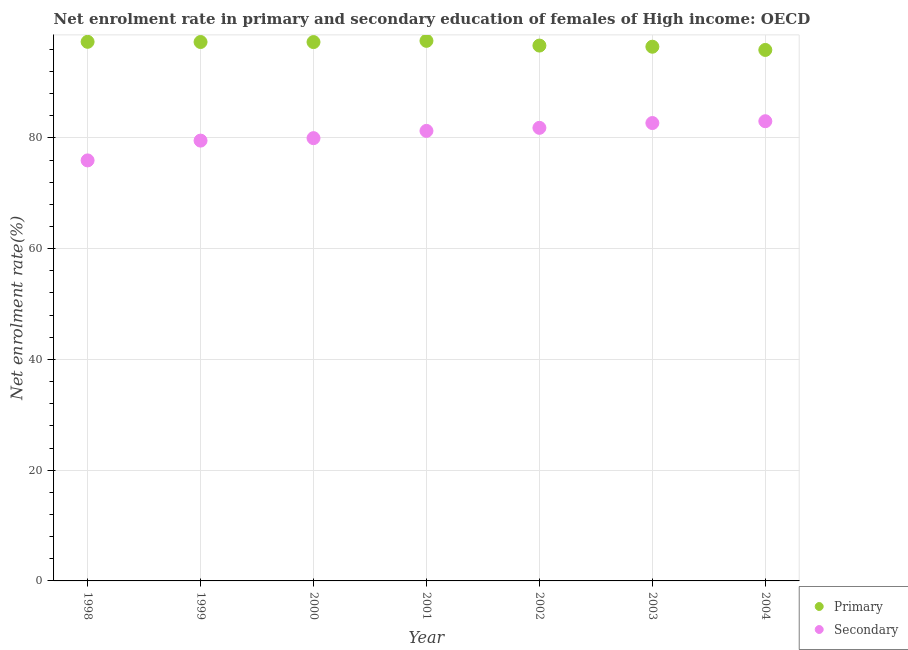How many different coloured dotlines are there?
Give a very brief answer. 2. Is the number of dotlines equal to the number of legend labels?
Your response must be concise. Yes. What is the enrollment rate in secondary education in 1998?
Offer a terse response. 75.95. Across all years, what is the maximum enrollment rate in primary education?
Make the answer very short. 97.54. Across all years, what is the minimum enrollment rate in secondary education?
Offer a very short reply. 75.95. In which year was the enrollment rate in primary education maximum?
Your response must be concise. 2001. What is the total enrollment rate in primary education in the graph?
Keep it short and to the point. 678.61. What is the difference between the enrollment rate in primary education in 2000 and that in 2002?
Make the answer very short. 0.63. What is the difference between the enrollment rate in secondary education in 2000 and the enrollment rate in primary education in 2004?
Keep it short and to the point. -15.93. What is the average enrollment rate in secondary education per year?
Provide a short and direct response. 80.61. In the year 2002, what is the difference between the enrollment rate in secondary education and enrollment rate in primary education?
Make the answer very short. -14.86. In how many years, is the enrollment rate in secondary education greater than 92 %?
Give a very brief answer. 0. What is the ratio of the enrollment rate in secondary education in 1998 to that in 2001?
Provide a succinct answer. 0.93. Is the enrollment rate in secondary education in 1999 less than that in 2001?
Give a very brief answer. Yes. Is the difference between the enrollment rate in secondary education in 2001 and 2002 greater than the difference between the enrollment rate in primary education in 2001 and 2002?
Offer a terse response. No. What is the difference between the highest and the second highest enrollment rate in primary education?
Give a very brief answer. 0.17. What is the difference between the highest and the lowest enrollment rate in secondary education?
Your answer should be very brief. 7.08. Is the sum of the enrollment rate in primary education in 1998 and 2004 greater than the maximum enrollment rate in secondary education across all years?
Your answer should be compact. Yes. Is the enrollment rate in secondary education strictly less than the enrollment rate in primary education over the years?
Your answer should be compact. Yes. How many dotlines are there?
Offer a very short reply. 2. How many years are there in the graph?
Offer a terse response. 7. Does the graph contain any zero values?
Ensure brevity in your answer.  No. Where does the legend appear in the graph?
Offer a terse response. Bottom right. How are the legend labels stacked?
Keep it short and to the point. Vertical. What is the title of the graph?
Keep it short and to the point. Net enrolment rate in primary and secondary education of females of High income: OECD. Does "Boys" appear as one of the legend labels in the graph?
Your answer should be compact. No. What is the label or title of the X-axis?
Provide a succinct answer. Year. What is the label or title of the Y-axis?
Your response must be concise. Net enrolment rate(%). What is the Net enrolment rate(%) in Primary in 1998?
Your answer should be very brief. 97.36. What is the Net enrolment rate(%) in Secondary in 1998?
Make the answer very short. 75.95. What is the Net enrolment rate(%) in Primary in 1999?
Your answer should be compact. 97.33. What is the Net enrolment rate(%) of Secondary in 1999?
Give a very brief answer. 79.52. What is the Net enrolment rate(%) in Primary in 2000?
Your response must be concise. 97.32. What is the Net enrolment rate(%) in Secondary in 2000?
Give a very brief answer. 79.97. What is the Net enrolment rate(%) in Primary in 2001?
Make the answer very short. 97.54. What is the Net enrolment rate(%) in Secondary in 2001?
Offer a terse response. 81.28. What is the Net enrolment rate(%) of Primary in 2002?
Provide a short and direct response. 96.69. What is the Net enrolment rate(%) of Secondary in 2002?
Your answer should be compact. 81.83. What is the Net enrolment rate(%) in Primary in 2003?
Your answer should be compact. 96.48. What is the Net enrolment rate(%) in Secondary in 2003?
Provide a succinct answer. 82.69. What is the Net enrolment rate(%) of Primary in 2004?
Your answer should be compact. 95.9. What is the Net enrolment rate(%) of Secondary in 2004?
Offer a terse response. 83.02. Across all years, what is the maximum Net enrolment rate(%) in Primary?
Make the answer very short. 97.54. Across all years, what is the maximum Net enrolment rate(%) in Secondary?
Offer a very short reply. 83.02. Across all years, what is the minimum Net enrolment rate(%) in Primary?
Your answer should be compact. 95.9. Across all years, what is the minimum Net enrolment rate(%) of Secondary?
Keep it short and to the point. 75.95. What is the total Net enrolment rate(%) in Primary in the graph?
Ensure brevity in your answer.  678.61. What is the total Net enrolment rate(%) in Secondary in the graph?
Offer a terse response. 564.26. What is the difference between the Net enrolment rate(%) in Primary in 1998 and that in 1999?
Your response must be concise. 0.04. What is the difference between the Net enrolment rate(%) in Secondary in 1998 and that in 1999?
Provide a succinct answer. -3.58. What is the difference between the Net enrolment rate(%) in Primary in 1998 and that in 2000?
Offer a terse response. 0.05. What is the difference between the Net enrolment rate(%) in Secondary in 1998 and that in 2000?
Offer a terse response. -4.02. What is the difference between the Net enrolment rate(%) in Primary in 1998 and that in 2001?
Your response must be concise. -0.17. What is the difference between the Net enrolment rate(%) of Secondary in 1998 and that in 2001?
Give a very brief answer. -5.33. What is the difference between the Net enrolment rate(%) in Primary in 1998 and that in 2002?
Provide a short and direct response. 0.68. What is the difference between the Net enrolment rate(%) in Secondary in 1998 and that in 2002?
Offer a terse response. -5.88. What is the difference between the Net enrolment rate(%) of Primary in 1998 and that in 2003?
Make the answer very short. 0.89. What is the difference between the Net enrolment rate(%) of Secondary in 1998 and that in 2003?
Provide a succinct answer. -6.75. What is the difference between the Net enrolment rate(%) of Primary in 1998 and that in 2004?
Provide a short and direct response. 1.47. What is the difference between the Net enrolment rate(%) in Secondary in 1998 and that in 2004?
Make the answer very short. -7.08. What is the difference between the Net enrolment rate(%) in Primary in 1999 and that in 2000?
Provide a succinct answer. 0.01. What is the difference between the Net enrolment rate(%) of Secondary in 1999 and that in 2000?
Your response must be concise. -0.45. What is the difference between the Net enrolment rate(%) of Primary in 1999 and that in 2001?
Keep it short and to the point. -0.21. What is the difference between the Net enrolment rate(%) of Secondary in 1999 and that in 2001?
Make the answer very short. -1.75. What is the difference between the Net enrolment rate(%) in Primary in 1999 and that in 2002?
Provide a short and direct response. 0.64. What is the difference between the Net enrolment rate(%) in Secondary in 1999 and that in 2002?
Offer a terse response. -2.31. What is the difference between the Net enrolment rate(%) of Primary in 1999 and that in 2003?
Make the answer very short. 0.85. What is the difference between the Net enrolment rate(%) in Secondary in 1999 and that in 2003?
Offer a very short reply. -3.17. What is the difference between the Net enrolment rate(%) in Primary in 1999 and that in 2004?
Keep it short and to the point. 1.43. What is the difference between the Net enrolment rate(%) of Secondary in 1999 and that in 2004?
Your answer should be compact. -3.5. What is the difference between the Net enrolment rate(%) in Primary in 2000 and that in 2001?
Your response must be concise. -0.22. What is the difference between the Net enrolment rate(%) of Secondary in 2000 and that in 2001?
Ensure brevity in your answer.  -1.31. What is the difference between the Net enrolment rate(%) in Primary in 2000 and that in 2002?
Make the answer very short. 0.63. What is the difference between the Net enrolment rate(%) of Secondary in 2000 and that in 2002?
Offer a very short reply. -1.86. What is the difference between the Net enrolment rate(%) of Primary in 2000 and that in 2003?
Your answer should be very brief. 0.84. What is the difference between the Net enrolment rate(%) in Secondary in 2000 and that in 2003?
Offer a very short reply. -2.73. What is the difference between the Net enrolment rate(%) of Primary in 2000 and that in 2004?
Provide a short and direct response. 1.42. What is the difference between the Net enrolment rate(%) of Secondary in 2000 and that in 2004?
Offer a very short reply. -3.06. What is the difference between the Net enrolment rate(%) in Primary in 2001 and that in 2002?
Provide a succinct answer. 0.85. What is the difference between the Net enrolment rate(%) in Secondary in 2001 and that in 2002?
Offer a terse response. -0.55. What is the difference between the Net enrolment rate(%) of Primary in 2001 and that in 2003?
Offer a very short reply. 1.06. What is the difference between the Net enrolment rate(%) of Secondary in 2001 and that in 2003?
Provide a succinct answer. -1.42. What is the difference between the Net enrolment rate(%) of Primary in 2001 and that in 2004?
Offer a terse response. 1.64. What is the difference between the Net enrolment rate(%) in Secondary in 2001 and that in 2004?
Your answer should be compact. -1.75. What is the difference between the Net enrolment rate(%) in Primary in 2002 and that in 2003?
Your answer should be compact. 0.21. What is the difference between the Net enrolment rate(%) of Secondary in 2002 and that in 2003?
Your answer should be compact. -0.87. What is the difference between the Net enrolment rate(%) in Primary in 2002 and that in 2004?
Offer a very short reply. 0.79. What is the difference between the Net enrolment rate(%) of Secondary in 2002 and that in 2004?
Provide a short and direct response. -1.2. What is the difference between the Net enrolment rate(%) of Primary in 2003 and that in 2004?
Your response must be concise. 0.58. What is the difference between the Net enrolment rate(%) of Secondary in 2003 and that in 2004?
Provide a succinct answer. -0.33. What is the difference between the Net enrolment rate(%) of Primary in 1998 and the Net enrolment rate(%) of Secondary in 1999?
Your answer should be compact. 17.84. What is the difference between the Net enrolment rate(%) of Primary in 1998 and the Net enrolment rate(%) of Secondary in 2000?
Your response must be concise. 17.4. What is the difference between the Net enrolment rate(%) in Primary in 1998 and the Net enrolment rate(%) in Secondary in 2001?
Provide a short and direct response. 16.09. What is the difference between the Net enrolment rate(%) of Primary in 1998 and the Net enrolment rate(%) of Secondary in 2002?
Your response must be concise. 15.54. What is the difference between the Net enrolment rate(%) of Primary in 1998 and the Net enrolment rate(%) of Secondary in 2003?
Offer a very short reply. 14.67. What is the difference between the Net enrolment rate(%) in Primary in 1998 and the Net enrolment rate(%) in Secondary in 2004?
Offer a very short reply. 14.34. What is the difference between the Net enrolment rate(%) in Primary in 1999 and the Net enrolment rate(%) in Secondary in 2000?
Make the answer very short. 17.36. What is the difference between the Net enrolment rate(%) in Primary in 1999 and the Net enrolment rate(%) in Secondary in 2001?
Provide a short and direct response. 16.05. What is the difference between the Net enrolment rate(%) of Primary in 1999 and the Net enrolment rate(%) of Secondary in 2002?
Provide a succinct answer. 15.5. What is the difference between the Net enrolment rate(%) of Primary in 1999 and the Net enrolment rate(%) of Secondary in 2003?
Give a very brief answer. 14.63. What is the difference between the Net enrolment rate(%) in Primary in 1999 and the Net enrolment rate(%) in Secondary in 2004?
Make the answer very short. 14.3. What is the difference between the Net enrolment rate(%) of Primary in 2000 and the Net enrolment rate(%) of Secondary in 2001?
Ensure brevity in your answer.  16.04. What is the difference between the Net enrolment rate(%) of Primary in 2000 and the Net enrolment rate(%) of Secondary in 2002?
Give a very brief answer. 15.49. What is the difference between the Net enrolment rate(%) of Primary in 2000 and the Net enrolment rate(%) of Secondary in 2003?
Your response must be concise. 14.62. What is the difference between the Net enrolment rate(%) of Primary in 2000 and the Net enrolment rate(%) of Secondary in 2004?
Provide a succinct answer. 14.29. What is the difference between the Net enrolment rate(%) of Primary in 2001 and the Net enrolment rate(%) of Secondary in 2002?
Your response must be concise. 15.71. What is the difference between the Net enrolment rate(%) in Primary in 2001 and the Net enrolment rate(%) in Secondary in 2003?
Your response must be concise. 14.84. What is the difference between the Net enrolment rate(%) in Primary in 2001 and the Net enrolment rate(%) in Secondary in 2004?
Ensure brevity in your answer.  14.51. What is the difference between the Net enrolment rate(%) in Primary in 2002 and the Net enrolment rate(%) in Secondary in 2003?
Keep it short and to the point. 13.99. What is the difference between the Net enrolment rate(%) in Primary in 2002 and the Net enrolment rate(%) in Secondary in 2004?
Give a very brief answer. 13.66. What is the difference between the Net enrolment rate(%) in Primary in 2003 and the Net enrolment rate(%) in Secondary in 2004?
Provide a succinct answer. 13.45. What is the average Net enrolment rate(%) of Primary per year?
Make the answer very short. 96.94. What is the average Net enrolment rate(%) of Secondary per year?
Make the answer very short. 80.61. In the year 1998, what is the difference between the Net enrolment rate(%) of Primary and Net enrolment rate(%) of Secondary?
Give a very brief answer. 21.42. In the year 1999, what is the difference between the Net enrolment rate(%) of Primary and Net enrolment rate(%) of Secondary?
Keep it short and to the point. 17.81. In the year 2000, what is the difference between the Net enrolment rate(%) of Primary and Net enrolment rate(%) of Secondary?
Your answer should be very brief. 17.35. In the year 2001, what is the difference between the Net enrolment rate(%) in Primary and Net enrolment rate(%) in Secondary?
Your response must be concise. 16.26. In the year 2002, what is the difference between the Net enrolment rate(%) in Primary and Net enrolment rate(%) in Secondary?
Provide a succinct answer. 14.86. In the year 2003, what is the difference between the Net enrolment rate(%) in Primary and Net enrolment rate(%) in Secondary?
Offer a terse response. 13.78. In the year 2004, what is the difference between the Net enrolment rate(%) of Primary and Net enrolment rate(%) of Secondary?
Make the answer very short. 12.87. What is the ratio of the Net enrolment rate(%) in Primary in 1998 to that in 1999?
Give a very brief answer. 1. What is the ratio of the Net enrolment rate(%) of Secondary in 1998 to that in 1999?
Offer a terse response. 0.95. What is the ratio of the Net enrolment rate(%) of Secondary in 1998 to that in 2000?
Offer a terse response. 0.95. What is the ratio of the Net enrolment rate(%) of Secondary in 1998 to that in 2001?
Keep it short and to the point. 0.93. What is the ratio of the Net enrolment rate(%) in Primary in 1998 to that in 2002?
Your answer should be compact. 1.01. What is the ratio of the Net enrolment rate(%) in Secondary in 1998 to that in 2002?
Keep it short and to the point. 0.93. What is the ratio of the Net enrolment rate(%) of Primary in 1998 to that in 2003?
Offer a terse response. 1.01. What is the ratio of the Net enrolment rate(%) in Secondary in 1998 to that in 2003?
Your answer should be compact. 0.92. What is the ratio of the Net enrolment rate(%) of Primary in 1998 to that in 2004?
Offer a terse response. 1.02. What is the ratio of the Net enrolment rate(%) in Secondary in 1998 to that in 2004?
Your answer should be compact. 0.91. What is the ratio of the Net enrolment rate(%) in Primary in 1999 to that in 2000?
Provide a succinct answer. 1. What is the ratio of the Net enrolment rate(%) in Secondary in 1999 to that in 2000?
Your response must be concise. 0.99. What is the ratio of the Net enrolment rate(%) in Primary in 1999 to that in 2001?
Your response must be concise. 1. What is the ratio of the Net enrolment rate(%) in Secondary in 1999 to that in 2001?
Keep it short and to the point. 0.98. What is the ratio of the Net enrolment rate(%) of Secondary in 1999 to that in 2002?
Give a very brief answer. 0.97. What is the ratio of the Net enrolment rate(%) of Primary in 1999 to that in 2003?
Your answer should be very brief. 1.01. What is the ratio of the Net enrolment rate(%) in Secondary in 1999 to that in 2003?
Your response must be concise. 0.96. What is the ratio of the Net enrolment rate(%) in Primary in 1999 to that in 2004?
Provide a succinct answer. 1.01. What is the ratio of the Net enrolment rate(%) in Secondary in 1999 to that in 2004?
Make the answer very short. 0.96. What is the ratio of the Net enrolment rate(%) of Primary in 2000 to that in 2001?
Offer a very short reply. 1. What is the ratio of the Net enrolment rate(%) in Secondary in 2000 to that in 2001?
Offer a terse response. 0.98. What is the ratio of the Net enrolment rate(%) in Primary in 2000 to that in 2002?
Your response must be concise. 1.01. What is the ratio of the Net enrolment rate(%) of Secondary in 2000 to that in 2002?
Your answer should be very brief. 0.98. What is the ratio of the Net enrolment rate(%) in Primary in 2000 to that in 2003?
Give a very brief answer. 1.01. What is the ratio of the Net enrolment rate(%) of Primary in 2000 to that in 2004?
Offer a very short reply. 1.01. What is the ratio of the Net enrolment rate(%) in Secondary in 2000 to that in 2004?
Provide a short and direct response. 0.96. What is the ratio of the Net enrolment rate(%) of Primary in 2001 to that in 2002?
Your response must be concise. 1.01. What is the ratio of the Net enrolment rate(%) of Secondary in 2001 to that in 2003?
Keep it short and to the point. 0.98. What is the ratio of the Net enrolment rate(%) of Primary in 2001 to that in 2004?
Your answer should be very brief. 1.02. What is the ratio of the Net enrolment rate(%) in Secondary in 2001 to that in 2004?
Offer a terse response. 0.98. What is the ratio of the Net enrolment rate(%) in Primary in 2002 to that in 2004?
Make the answer very short. 1.01. What is the ratio of the Net enrolment rate(%) of Secondary in 2002 to that in 2004?
Ensure brevity in your answer.  0.99. What is the ratio of the Net enrolment rate(%) of Primary in 2003 to that in 2004?
Make the answer very short. 1.01. What is the ratio of the Net enrolment rate(%) in Secondary in 2003 to that in 2004?
Give a very brief answer. 1. What is the difference between the highest and the second highest Net enrolment rate(%) in Primary?
Offer a terse response. 0.17. What is the difference between the highest and the second highest Net enrolment rate(%) of Secondary?
Keep it short and to the point. 0.33. What is the difference between the highest and the lowest Net enrolment rate(%) in Primary?
Keep it short and to the point. 1.64. What is the difference between the highest and the lowest Net enrolment rate(%) of Secondary?
Give a very brief answer. 7.08. 